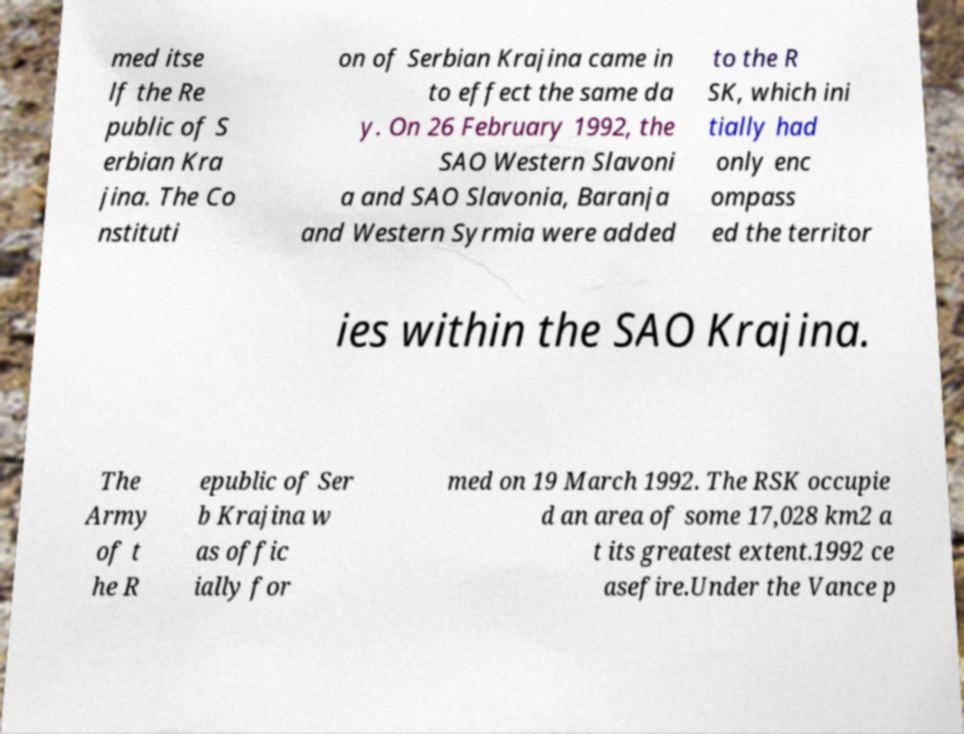Can you read and provide the text displayed in the image?This photo seems to have some interesting text. Can you extract and type it out for me? med itse lf the Re public of S erbian Kra jina. The Co nstituti on of Serbian Krajina came in to effect the same da y. On 26 February 1992, the SAO Western Slavoni a and SAO Slavonia, Baranja and Western Syrmia were added to the R SK, which ini tially had only enc ompass ed the territor ies within the SAO Krajina. The Army of t he R epublic of Ser b Krajina w as offic ially for med on 19 March 1992. The RSK occupie d an area of some 17,028 km2 a t its greatest extent.1992 ce asefire.Under the Vance p 